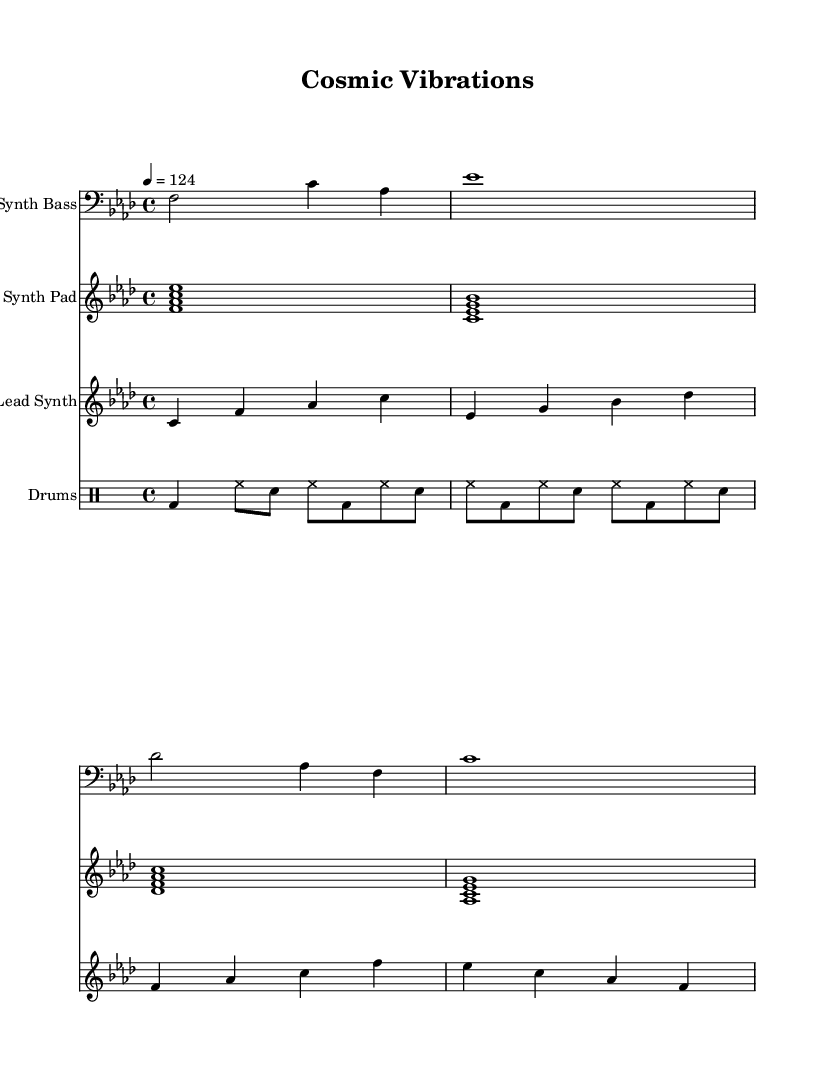What is the key signature of this music? The key signature shows 4 flats, indicating it is in F minor. The flats indicated are B, E, A, and D.
Answer: F minor What is the time signature of this music? The time signature is indicated at the beginning of the score as 4/4, which means there are four beats in each measure.
Answer: 4/4 What is the tempo marking of this music? The tempo marking is indicated as "4 = 124", which means there are 124 beats per minute in the piece.
Answer: 124 How many measures are in the synth bass part? By counting the measures represented in the synth bass notation, there are a total of 4 measures.
Answer: 4 What kind of instrument is used for the drum pattern? The drum pattern is written in a dedicated "DrumStaff," which is specifically for percussion instruments, confirming it is drums.
Answer: Drums What is the primary harmony used in the synth pad? The harmony depicted consists of chords based on the notes F, A flat, C, and E flat, indicating the use of F minor chords throughout its progression.
Answer: F minor How does the lead synth contribute to the overall texture of the composition? By providing melodic lines that complement the harmonies laid down by the synth pad, the lead synth adds a melodic layer that interacts with the rhythm and harmony, enhancing the overall texture.
Answer: Melodic layer 